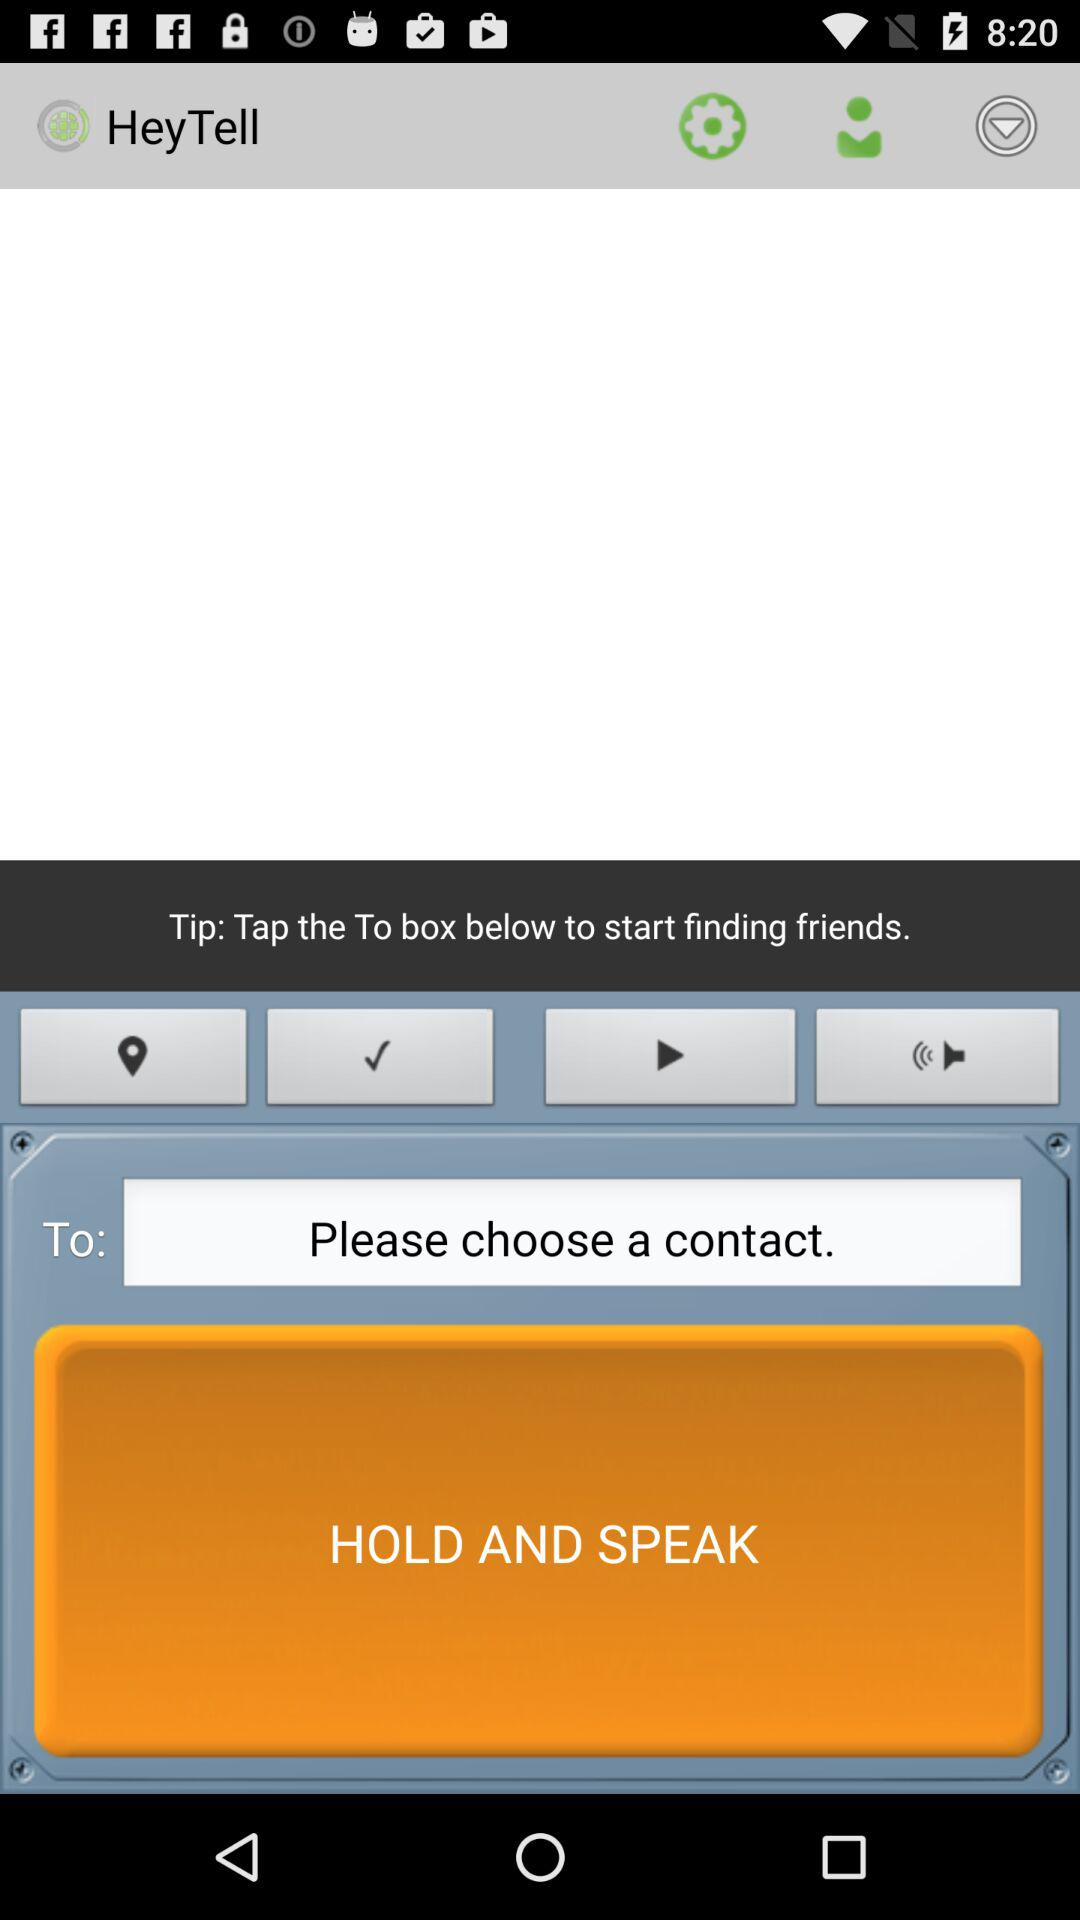What's the tip? The tip is "Tap the To box below to start finding friends". 